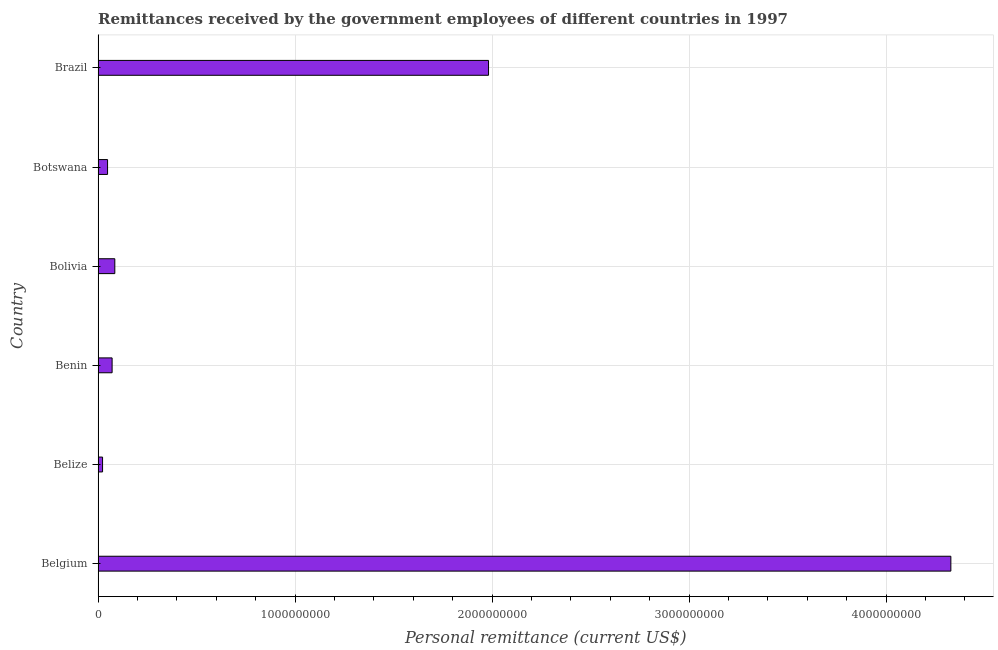Does the graph contain any zero values?
Give a very brief answer. No. What is the title of the graph?
Provide a short and direct response. Remittances received by the government employees of different countries in 1997. What is the label or title of the X-axis?
Your answer should be very brief. Personal remittance (current US$). What is the personal remittances in Botswana?
Offer a terse response. 4.82e+07. Across all countries, what is the maximum personal remittances?
Keep it short and to the point. 4.33e+09. Across all countries, what is the minimum personal remittances?
Offer a very short reply. 2.27e+07. In which country was the personal remittances maximum?
Provide a short and direct response. Belgium. In which country was the personal remittances minimum?
Make the answer very short. Belize. What is the sum of the personal remittances?
Offer a very short reply. 6.54e+09. What is the difference between the personal remittances in Botswana and Brazil?
Ensure brevity in your answer.  -1.93e+09. What is the average personal remittances per country?
Your answer should be compact. 1.09e+09. What is the median personal remittances?
Your answer should be compact. 7.81e+07. In how many countries, is the personal remittances greater than 3000000000 US$?
Ensure brevity in your answer.  1. What is the ratio of the personal remittances in Belize to that in Benin?
Keep it short and to the point. 0.32. Is the difference between the personal remittances in Belize and Benin greater than the difference between any two countries?
Provide a succinct answer. No. What is the difference between the highest and the second highest personal remittances?
Offer a terse response. 2.35e+09. What is the difference between the highest and the lowest personal remittances?
Your response must be concise. 4.31e+09. In how many countries, is the personal remittances greater than the average personal remittances taken over all countries?
Offer a terse response. 2. Are all the bars in the graph horizontal?
Your answer should be compact. Yes. How many countries are there in the graph?
Your answer should be compact. 6. Are the values on the major ticks of X-axis written in scientific E-notation?
Your response must be concise. No. What is the Personal remittance (current US$) of Belgium?
Give a very brief answer. 4.33e+09. What is the Personal remittance (current US$) of Belize?
Give a very brief answer. 2.27e+07. What is the Personal remittance (current US$) in Benin?
Keep it short and to the point. 7.12e+07. What is the Personal remittance (current US$) of Bolivia?
Ensure brevity in your answer.  8.49e+07. What is the Personal remittance (current US$) of Botswana?
Provide a short and direct response. 4.82e+07. What is the Personal remittance (current US$) in Brazil?
Offer a very short reply. 1.98e+09. What is the difference between the Personal remittance (current US$) in Belgium and Belize?
Offer a very short reply. 4.31e+09. What is the difference between the Personal remittance (current US$) in Belgium and Benin?
Provide a succinct answer. 4.26e+09. What is the difference between the Personal remittance (current US$) in Belgium and Bolivia?
Give a very brief answer. 4.24e+09. What is the difference between the Personal remittance (current US$) in Belgium and Botswana?
Your answer should be very brief. 4.28e+09. What is the difference between the Personal remittance (current US$) in Belgium and Brazil?
Provide a short and direct response. 2.35e+09. What is the difference between the Personal remittance (current US$) in Belize and Benin?
Ensure brevity in your answer.  -4.85e+07. What is the difference between the Personal remittance (current US$) in Belize and Bolivia?
Provide a short and direct response. -6.22e+07. What is the difference between the Personal remittance (current US$) in Belize and Botswana?
Your response must be concise. -2.55e+07. What is the difference between the Personal remittance (current US$) in Belize and Brazil?
Make the answer very short. -1.96e+09. What is the difference between the Personal remittance (current US$) in Benin and Bolivia?
Ensure brevity in your answer.  -1.37e+07. What is the difference between the Personal remittance (current US$) in Benin and Botswana?
Your answer should be very brief. 2.31e+07. What is the difference between the Personal remittance (current US$) in Benin and Brazil?
Your response must be concise. -1.91e+09. What is the difference between the Personal remittance (current US$) in Bolivia and Botswana?
Offer a very short reply. 3.67e+07. What is the difference between the Personal remittance (current US$) in Bolivia and Brazil?
Offer a terse response. -1.90e+09. What is the difference between the Personal remittance (current US$) in Botswana and Brazil?
Offer a terse response. -1.93e+09. What is the ratio of the Personal remittance (current US$) in Belgium to that in Belize?
Offer a very short reply. 190.7. What is the ratio of the Personal remittance (current US$) in Belgium to that in Benin?
Offer a terse response. 60.77. What is the ratio of the Personal remittance (current US$) in Belgium to that in Bolivia?
Your answer should be very brief. 50.99. What is the ratio of the Personal remittance (current US$) in Belgium to that in Botswana?
Ensure brevity in your answer.  89.89. What is the ratio of the Personal remittance (current US$) in Belgium to that in Brazil?
Offer a very short reply. 2.18. What is the ratio of the Personal remittance (current US$) in Belize to that in Benin?
Offer a very short reply. 0.32. What is the ratio of the Personal remittance (current US$) in Belize to that in Bolivia?
Offer a terse response. 0.27. What is the ratio of the Personal remittance (current US$) in Belize to that in Botswana?
Make the answer very short. 0.47. What is the ratio of the Personal remittance (current US$) in Belize to that in Brazil?
Provide a succinct answer. 0.01. What is the ratio of the Personal remittance (current US$) in Benin to that in Bolivia?
Ensure brevity in your answer.  0.84. What is the ratio of the Personal remittance (current US$) in Benin to that in Botswana?
Provide a short and direct response. 1.48. What is the ratio of the Personal remittance (current US$) in Benin to that in Brazil?
Give a very brief answer. 0.04. What is the ratio of the Personal remittance (current US$) in Bolivia to that in Botswana?
Your answer should be very brief. 1.76. What is the ratio of the Personal remittance (current US$) in Bolivia to that in Brazil?
Keep it short and to the point. 0.04. What is the ratio of the Personal remittance (current US$) in Botswana to that in Brazil?
Offer a terse response. 0.02. 